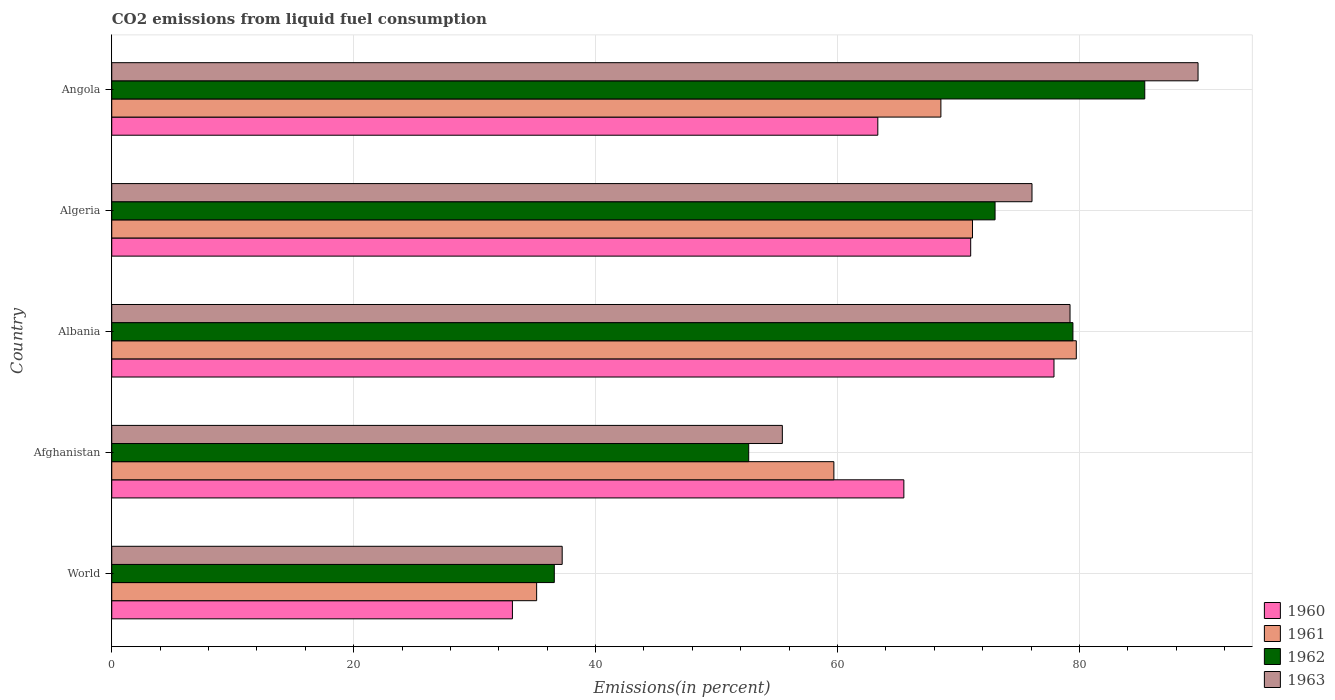How many groups of bars are there?
Provide a succinct answer. 5. Are the number of bars per tick equal to the number of legend labels?
Make the answer very short. Yes. How many bars are there on the 5th tick from the bottom?
Give a very brief answer. 4. What is the label of the 2nd group of bars from the top?
Your answer should be compact. Algeria. In how many cases, is the number of bars for a given country not equal to the number of legend labels?
Ensure brevity in your answer.  0. What is the total CO2 emitted in 1960 in World?
Provide a short and direct response. 33.13. Across all countries, what is the maximum total CO2 emitted in 1963?
Provide a succinct answer. 89.81. Across all countries, what is the minimum total CO2 emitted in 1961?
Offer a very short reply. 35.13. In which country was the total CO2 emitted in 1963 maximum?
Make the answer very short. Angola. In which country was the total CO2 emitted in 1961 minimum?
Ensure brevity in your answer.  World. What is the total total CO2 emitted in 1962 in the graph?
Provide a succinct answer. 327.14. What is the difference between the total CO2 emitted in 1961 in Afghanistan and that in World?
Your response must be concise. 24.57. What is the difference between the total CO2 emitted in 1960 in World and the total CO2 emitted in 1961 in Angola?
Offer a very short reply. -35.42. What is the average total CO2 emitted in 1962 per country?
Ensure brevity in your answer.  65.43. What is the difference between the total CO2 emitted in 1962 and total CO2 emitted in 1960 in Albania?
Your answer should be very brief. 1.57. In how many countries, is the total CO2 emitted in 1961 greater than 44 %?
Your answer should be compact. 4. What is the ratio of the total CO2 emitted in 1961 in Albania to that in World?
Offer a terse response. 2.27. What is the difference between the highest and the second highest total CO2 emitted in 1963?
Offer a terse response. 10.58. What is the difference between the highest and the lowest total CO2 emitted in 1962?
Your response must be concise. 48.82. In how many countries, is the total CO2 emitted in 1961 greater than the average total CO2 emitted in 1961 taken over all countries?
Your answer should be very brief. 3. Is the sum of the total CO2 emitted in 1961 in Albania and World greater than the maximum total CO2 emitted in 1963 across all countries?
Your response must be concise. Yes. Is it the case that in every country, the sum of the total CO2 emitted in 1961 and total CO2 emitted in 1962 is greater than the sum of total CO2 emitted in 1960 and total CO2 emitted in 1963?
Keep it short and to the point. No. What does the 2nd bar from the top in Algeria represents?
Your answer should be compact. 1962. What is the difference between two consecutive major ticks on the X-axis?
Your response must be concise. 20. Are the values on the major ticks of X-axis written in scientific E-notation?
Your response must be concise. No. Does the graph contain grids?
Provide a short and direct response. Yes. Where does the legend appear in the graph?
Your answer should be compact. Bottom right. How many legend labels are there?
Your answer should be compact. 4. What is the title of the graph?
Give a very brief answer. CO2 emissions from liquid fuel consumption. What is the label or title of the X-axis?
Provide a succinct answer. Emissions(in percent). What is the Emissions(in percent) in 1960 in World?
Keep it short and to the point. 33.13. What is the Emissions(in percent) in 1961 in World?
Your response must be concise. 35.13. What is the Emissions(in percent) of 1962 in World?
Make the answer very short. 36.59. What is the Emissions(in percent) in 1963 in World?
Give a very brief answer. 37.24. What is the Emissions(in percent) of 1960 in Afghanistan?
Your answer should be very brief. 65.49. What is the Emissions(in percent) of 1961 in Afghanistan?
Keep it short and to the point. 59.7. What is the Emissions(in percent) of 1962 in Afghanistan?
Provide a short and direct response. 52.66. What is the Emissions(in percent) of 1963 in Afghanistan?
Your answer should be very brief. 55.44. What is the Emissions(in percent) of 1960 in Albania?
Offer a terse response. 77.9. What is the Emissions(in percent) in 1961 in Albania?
Provide a short and direct response. 79.74. What is the Emissions(in percent) in 1962 in Albania?
Offer a terse response. 79.46. What is the Emissions(in percent) of 1963 in Albania?
Give a very brief answer. 79.23. What is the Emissions(in percent) in 1960 in Algeria?
Make the answer very short. 71.01. What is the Emissions(in percent) in 1961 in Algeria?
Make the answer very short. 71.16. What is the Emissions(in percent) in 1962 in Algeria?
Your response must be concise. 73.03. What is the Emissions(in percent) of 1963 in Algeria?
Your answer should be compact. 76.08. What is the Emissions(in percent) of 1960 in Angola?
Offer a very short reply. 63.33. What is the Emissions(in percent) of 1961 in Angola?
Make the answer very short. 68.55. What is the Emissions(in percent) in 1962 in Angola?
Offer a terse response. 85.4. What is the Emissions(in percent) of 1963 in Angola?
Provide a succinct answer. 89.81. Across all countries, what is the maximum Emissions(in percent) of 1960?
Your answer should be very brief. 77.9. Across all countries, what is the maximum Emissions(in percent) in 1961?
Offer a very short reply. 79.74. Across all countries, what is the maximum Emissions(in percent) in 1962?
Your answer should be very brief. 85.4. Across all countries, what is the maximum Emissions(in percent) in 1963?
Your answer should be very brief. 89.81. Across all countries, what is the minimum Emissions(in percent) in 1960?
Keep it short and to the point. 33.13. Across all countries, what is the minimum Emissions(in percent) in 1961?
Give a very brief answer. 35.13. Across all countries, what is the minimum Emissions(in percent) in 1962?
Your answer should be compact. 36.59. Across all countries, what is the minimum Emissions(in percent) of 1963?
Ensure brevity in your answer.  37.24. What is the total Emissions(in percent) of 1960 in the graph?
Your response must be concise. 310.86. What is the total Emissions(in percent) in 1961 in the graph?
Your answer should be very brief. 314.28. What is the total Emissions(in percent) in 1962 in the graph?
Offer a very short reply. 327.14. What is the total Emissions(in percent) of 1963 in the graph?
Provide a succinct answer. 337.8. What is the difference between the Emissions(in percent) in 1960 in World and that in Afghanistan?
Your answer should be very brief. -32.36. What is the difference between the Emissions(in percent) of 1961 in World and that in Afghanistan?
Ensure brevity in your answer.  -24.57. What is the difference between the Emissions(in percent) of 1962 in World and that in Afghanistan?
Give a very brief answer. -16.07. What is the difference between the Emissions(in percent) of 1963 in World and that in Afghanistan?
Provide a short and direct response. -18.2. What is the difference between the Emissions(in percent) in 1960 in World and that in Albania?
Provide a short and direct response. -44.77. What is the difference between the Emissions(in percent) in 1961 in World and that in Albania?
Your response must be concise. -44.61. What is the difference between the Emissions(in percent) of 1962 in World and that in Albania?
Provide a short and direct response. -42.88. What is the difference between the Emissions(in percent) of 1963 in World and that in Albania?
Provide a succinct answer. -41.99. What is the difference between the Emissions(in percent) in 1960 in World and that in Algeria?
Offer a terse response. -37.89. What is the difference between the Emissions(in percent) of 1961 in World and that in Algeria?
Keep it short and to the point. -36.03. What is the difference between the Emissions(in percent) of 1962 in World and that in Algeria?
Give a very brief answer. -36.44. What is the difference between the Emissions(in percent) of 1963 in World and that in Algeria?
Ensure brevity in your answer.  -38.84. What is the difference between the Emissions(in percent) in 1960 in World and that in Angola?
Ensure brevity in your answer.  -30.21. What is the difference between the Emissions(in percent) of 1961 in World and that in Angola?
Make the answer very short. -33.42. What is the difference between the Emissions(in percent) in 1962 in World and that in Angola?
Offer a very short reply. -48.82. What is the difference between the Emissions(in percent) of 1963 in World and that in Angola?
Your response must be concise. -52.57. What is the difference between the Emissions(in percent) of 1960 in Afghanistan and that in Albania?
Your answer should be compact. -12.41. What is the difference between the Emissions(in percent) of 1961 in Afghanistan and that in Albania?
Provide a succinct answer. -20.04. What is the difference between the Emissions(in percent) of 1962 in Afghanistan and that in Albania?
Keep it short and to the point. -26.8. What is the difference between the Emissions(in percent) of 1963 in Afghanistan and that in Albania?
Provide a short and direct response. -23.78. What is the difference between the Emissions(in percent) in 1960 in Afghanistan and that in Algeria?
Your answer should be very brief. -5.53. What is the difference between the Emissions(in percent) of 1961 in Afghanistan and that in Algeria?
Provide a succinct answer. -11.46. What is the difference between the Emissions(in percent) in 1962 in Afghanistan and that in Algeria?
Your response must be concise. -20.37. What is the difference between the Emissions(in percent) in 1963 in Afghanistan and that in Algeria?
Give a very brief answer. -20.64. What is the difference between the Emissions(in percent) in 1960 in Afghanistan and that in Angola?
Offer a terse response. 2.15. What is the difference between the Emissions(in percent) of 1961 in Afghanistan and that in Angola?
Your answer should be very brief. -8.85. What is the difference between the Emissions(in percent) in 1962 in Afghanistan and that in Angola?
Provide a succinct answer. -32.74. What is the difference between the Emissions(in percent) in 1963 in Afghanistan and that in Angola?
Keep it short and to the point. -34.37. What is the difference between the Emissions(in percent) in 1960 in Albania and that in Algeria?
Give a very brief answer. 6.89. What is the difference between the Emissions(in percent) of 1961 in Albania and that in Algeria?
Make the answer very short. 8.58. What is the difference between the Emissions(in percent) in 1962 in Albania and that in Algeria?
Offer a terse response. 6.44. What is the difference between the Emissions(in percent) in 1963 in Albania and that in Algeria?
Keep it short and to the point. 3.14. What is the difference between the Emissions(in percent) in 1960 in Albania and that in Angola?
Make the answer very short. 14.57. What is the difference between the Emissions(in percent) of 1961 in Albania and that in Angola?
Make the answer very short. 11.19. What is the difference between the Emissions(in percent) of 1962 in Albania and that in Angola?
Offer a terse response. -5.94. What is the difference between the Emissions(in percent) of 1963 in Albania and that in Angola?
Offer a terse response. -10.58. What is the difference between the Emissions(in percent) in 1960 in Algeria and that in Angola?
Keep it short and to the point. 7.68. What is the difference between the Emissions(in percent) of 1961 in Algeria and that in Angola?
Your answer should be very brief. 2.61. What is the difference between the Emissions(in percent) in 1962 in Algeria and that in Angola?
Keep it short and to the point. -12.38. What is the difference between the Emissions(in percent) in 1963 in Algeria and that in Angola?
Provide a short and direct response. -13.73. What is the difference between the Emissions(in percent) in 1960 in World and the Emissions(in percent) in 1961 in Afghanistan?
Your answer should be very brief. -26.58. What is the difference between the Emissions(in percent) in 1960 in World and the Emissions(in percent) in 1962 in Afghanistan?
Keep it short and to the point. -19.53. What is the difference between the Emissions(in percent) in 1960 in World and the Emissions(in percent) in 1963 in Afghanistan?
Offer a very short reply. -22.32. What is the difference between the Emissions(in percent) of 1961 in World and the Emissions(in percent) of 1962 in Afghanistan?
Offer a terse response. -17.53. What is the difference between the Emissions(in percent) of 1961 in World and the Emissions(in percent) of 1963 in Afghanistan?
Your answer should be compact. -20.31. What is the difference between the Emissions(in percent) of 1962 in World and the Emissions(in percent) of 1963 in Afghanistan?
Your answer should be compact. -18.85. What is the difference between the Emissions(in percent) of 1960 in World and the Emissions(in percent) of 1961 in Albania?
Offer a terse response. -46.62. What is the difference between the Emissions(in percent) in 1960 in World and the Emissions(in percent) in 1962 in Albania?
Your answer should be very brief. -46.34. What is the difference between the Emissions(in percent) in 1960 in World and the Emissions(in percent) in 1963 in Albania?
Offer a terse response. -46.1. What is the difference between the Emissions(in percent) in 1961 in World and the Emissions(in percent) in 1962 in Albania?
Your answer should be very brief. -44.34. What is the difference between the Emissions(in percent) of 1961 in World and the Emissions(in percent) of 1963 in Albania?
Offer a very short reply. -44.1. What is the difference between the Emissions(in percent) in 1962 in World and the Emissions(in percent) in 1963 in Albania?
Offer a very short reply. -42.64. What is the difference between the Emissions(in percent) of 1960 in World and the Emissions(in percent) of 1961 in Algeria?
Offer a very short reply. -38.04. What is the difference between the Emissions(in percent) of 1960 in World and the Emissions(in percent) of 1962 in Algeria?
Ensure brevity in your answer.  -39.9. What is the difference between the Emissions(in percent) of 1960 in World and the Emissions(in percent) of 1963 in Algeria?
Ensure brevity in your answer.  -42.96. What is the difference between the Emissions(in percent) in 1961 in World and the Emissions(in percent) in 1962 in Algeria?
Your answer should be very brief. -37.9. What is the difference between the Emissions(in percent) of 1961 in World and the Emissions(in percent) of 1963 in Algeria?
Provide a succinct answer. -40.95. What is the difference between the Emissions(in percent) of 1962 in World and the Emissions(in percent) of 1963 in Algeria?
Offer a terse response. -39.49. What is the difference between the Emissions(in percent) of 1960 in World and the Emissions(in percent) of 1961 in Angola?
Ensure brevity in your answer.  -35.42. What is the difference between the Emissions(in percent) in 1960 in World and the Emissions(in percent) in 1962 in Angola?
Keep it short and to the point. -52.28. What is the difference between the Emissions(in percent) in 1960 in World and the Emissions(in percent) in 1963 in Angola?
Provide a succinct answer. -56.68. What is the difference between the Emissions(in percent) in 1961 in World and the Emissions(in percent) in 1962 in Angola?
Your answer should be compact. -50.28. What is the difference between the Emissions(in percent) of 1961 in World and the Emissions(in percent) of 1963 in Angola?
Give a very brief answer. -54.68. What is the difference between the Emissions(in percent) of 1962 in World and the Emissions(in percent) of 1963 in Angola?
Provide a short and direct response. -53.22. What is the difference between the Emissions(in percent) of 1960 in Afghanistan and the Emissions(in percent) of 1961 in Albania?
Make the answer very short. -14.26. What is the difference between the Emissions(in percent) in 1960 in Afghanistan and the Emissions(in percent) in 1962 in Albania?
Ensure brevity in your answer.  -13.98. What is the difference between the Emissions(in percent) of 1960 in Afghanistan and the Emissions(in percent) of 1963 in Albania?
Offer a very short reply. -13.74. What is the difference between the Emissions(in percent) in 1961 in Afghanistan and the Emissions(in percent) in 1962 in Albania?
Your response must be concise. -19.76. What is the difference between the Emissions(in percent) of 1961 in Afghanistan and the Emissions(in percent) of 1963 in Albania?
Keep it short and to the point. -19.52. What is the difference between the Emissions(in percent) in 1962 in Afghanistan and the Emissions(in percent) in 1963 in Albania?
Provide a succinct answer. -26.57. What is the difference between the Emissions(in percent) of 1960 in Afghanistan and the Emissions(in percent) of 1961 in Algeria?
Give a very brief answer. -5.67. What is the difference between the Emissions(in percent) of 1960 in Afghanistan and the Emissions(in percent) of 1962 in Algeria?
Ensure brevity in your answer.  -7.54. What is the difference between the Emissions(in percent) in 1960 in Afghanistan and the Emissions(in percent) in 1963 in Algeria?
Give a very brief answer. -10.59. What is the difference between the Emissions(in percent) of 1961 in Afghanistan and the Emissions(in percent) of 1962 in Algeria?
Your answer should be compact. -13.33. What is the difference between the Emissions(in percent) of 1961 in Afghanistan and the Emissions(in percent) of 1963 in Algeria?
Give a very brief answer. -16.38. What is the difference between the Emissions(in percent) of 1962 in Afghanistan and the Emissions(in percent) of 1963 in Algeria?
Provide a succinct answer. -23.42. What is the difference between the Emissions(in percent) of 1960 in Afghanistan and the Emissions(in percent) of 1961 in Angola?
Give a very brief answer. -3.06. What is the difference between the Emissions(in percent) of 1960 in Afghanistan and the Emissions(in percent) of 1962 in Angola?
Ensure brevity in your answer.  -19.92. What is the difference between the Emissions(in percent) of 1960 in Afghanistan and the Emissions(in percent) of 1963 in Angola?
Ensure brevity in your answer.  -24.32. What is the difference between the Emissions(in percent) in 1961 in Afghanistan and the Emissions(in percent) in 1962 in Angola?
Offer a very short reply. -25.7. What is the difference between the Emissions(in percent) in 1961 in Afghanistan and the Emissions(in percent) in 1963 in Angola?
Keep it short and to the point. -30.11. What is the difference between the Emissions(in percent) of 1962 in Afghanistan and the Emissions(in percent) of 1963 in Angola?
Your answer should be compact. -37.15. What is the difference between the Emissions(in percent) in 1960 in Albania and the Emissions(in percent) in 1961 in Algeria?
Ensure brevity in your answer.  6.74. What is the difference between the Emissions(in percent) of 1960 in Albania and the Emissions(in percent) of 1962 in Algeria?
Your answer should be very brief. 4.87. What is the difference between the Emissions(in percent) in 1960 in Albania and the Emissions(in percent) in 1963 in Algeria?
Your answer should be very brief. 1.82. What is the difference between the Emissions(in percent) of 1961 in Albania and the Emissions(in percent) of 1962 in Algeria?
Provide a short and direct response. 6.72. What is the difference between the Emissions(in percent) of 1961 in Albania and the Emissions(in percent) of 1963 in Algeria?
Keep it short and to the point. 3.66. What is the difference between the Emissions(in percent) of 1962 in Albania and the Emissions(in percent) of 1963 in Algeria?
Provide a short and direct response. 3.38. What is the difference between the Emissions(in percent) of 1960 in Albania and the Emissions(in percent) of 1961 in Angola?
Ensure brevity in your answer.  9.35. What is the difference between the Emissions(in percent) in 1960 in Albania and the Emissions(in percent) in 1962 in Angola?
Ensure brevity in your answer.  -7.51. What is the difference between the Emissions(in percent) in 1960 in Albania and the Emissions(in percent) in 1963 in Angola?
Provide a succinct answer. -11.91. What is the difference between the Emissions(in percent) of 1961 in Albania and the Emissions(in percent) of 1962 in Angola?
Give a very brief answer. -5.66. What is the difference between the Emissions(in percent) of 1961 in Albania and the Emissions(in percent) of 1963 in Angola?
Offer a very short reply. -10.07. What is the difference between the Emissions(in percent) in 1962 in Albania and the Emissions(in percent) in 1963 in Angola?
Give a very brief answer. -10.34. What is the difference between the Emissions(in percent) in 1960 in Algeria and the Emissions(in percent) in 1961 in Angola?
Offer a very short reply. 2.46. What is the difference between the Emissions(in percent) in 1960 in Algeria and the Emissions(in percent) in 1962 in Angola?
Offer a terse response. -14.39. What is the difference between the Emissions(in percent) of 1960 in Algeria and the Emissions(in percent) of 1963 in Angola?
Offer a very short reply. -18.8. What is the difference between the Emissions(in percent) of 1961 in Algeria and the Emissions(in percent) of 1962 in Angola?
Offer a terse response. -14.24. What is the difference between the Emissions(in percent) of 1961 in Algeria and the Emissions(in percent) of 1963 in Angola?
Keep it short and to the point. -18.65. What is the difference between the Emissions(in percent) in 1962 in Algeria and the Emissions(in percent) in 1963 in Angola?
Your response must be concise. -16.78. What is the average Emissions(in percent) of 1960 per country?
Provide a succinct answer. 62.17. What is the average Emissions(in percent) of 1961 per country?
Provide a succinct answer. 62.86. What is the average Emissions(in percent) in 1962 per country?
Keep it short and to the point. 65.43. What is the average Emissions(in percent) in 1963 per country?
Ensure brevity in your answer.  67.56. What is the difference between the Emissions(in percent) in 1960 and Emissions(in percent) in 1961 in World?
Your answer should be compact. -2. What is the difference between the Emissions(in percent) in 1960 and Emissions(in percent) in 1962 in World?
Offer a very short reply. -3.46. What is the difference between the Emissions(in percent) in 1960 and Emissions(in percent) in 1963 in World?
Make the answer very short. -4.11. What is the difference between the Emissions(in percent) in 1961 and Emissions(in percent) in 1962 in World?
Provide a succinct answer. -1.46. What is the difference between the Emissions(in percent) of 1961 and Emissions(in percent) of 1963 in World?
Provide a succinct answer. -2.11. What is the difference between the Emissions(in percent) in 1962 and Emissions(in percent) in 1963 in World?
Your response must be concise. -0.65. What is the difference between the Emissions(in percent) of 1960 and Emissions(in percent) of 1961 in Afghanistan?
Provide a succinct answer. 5.79. What is the difference between the Emissions(in percent) in 1960 and Emissions(in percent) in 1962 in Afghanistan?
Your response must be concise. 12.83. What is the difference between the Emissions(in percent) in 1960 and Emissions(in percent) in 1963 in Afghanistan?
Provide a succinct answer. 10.05. What is the difference between the Emissions(in percent) in 1961 and Emissions(in percent) in 1962 in Afghanistan?
Keep it short and to the point. 7.04. What is the difference between the Emissions(in percent) of 1961 and Emissions(in percent) of 1963 in Afghanistan?
Your response must be concise. 4.26. What is the difference between the Emissions(in percent) of 1962 and Emissions(in percent) of 1963 in Afghanistan?
Ensure brevity in your answer.  -2.78. What is the difference between the Emissions(in percent) of 1960 and Emissions(in percent) of 1961 in Albania?
Provide a short and direct response. -1.84. What is the difference between the Emissions(in percent) of 1960 and Emissions(in percent) of 1962 in Albania?
Your answer should be very brief. -1.57. What is the difference between the Emissions(in percent) of 1960 and Emissions(in percent) of 1963 in Albania?
Provide a succinct answer. -1.33. What is the difference between the Emissions(in percent) in 1961 and Emissions(in percent) in 1962 in Albania?
Ensure brevity in your answer.  0.28. What is the difference between the Emissions(in percent) in 1961 and Emissions(in percent) in 1963 in Albania?
Keep it short and to the point. 0.52. What is the difference between the Emissions(in percent) of 1962 and Emissions(in percent) of 1963 in Albania?
Offer a very short reply. 0.24. What is the difference between the Emissions(in percent) of 1960 and Emissions(in percent) of 1961 in Algeria?
Your response must be concise. -0.15. What is the difference between the Emissions(in percent) of 1960 and Emissions(in percent) of 1962 in Algeria?
Give a very brief answer. -2.02. What is the difference between the Emissions(in percent) in 1960 and Emissions(in percent) in 1963 in Algeria?
Offer a very short reply. -5.07. What is the difference between the Emissions(in percent) in 1961 and Emissions(in percent) in 1962 in Algeria?
Your answer should be compact. -1.87. What is the difference between the Emissions(in percent) in 1961 and Emissions(in percent) in 1963 in Algeria?
Provide a short and direct response. -4.92. What is the difference between the Emissions(in percent) in 1962 and Emissions(in percent) in 1963 in Algeria?
Ensure brevity in your answer.  -3.05. What is the difference between the Emissions(in percent) in 1960 and Emissions(in percent) in 1961 in Angola?
Give a very brief answer. -5.22. What is the difference between the Emissions(in percent) of 1960 and Emissions(in percent) of 1962 in Angola?
Your answer should be compact. -22.07. What is the difference between the Emissions(in percent) of 1960 and Emissions(in percent) of 1963 in Angola?
Offer a terse response. -26.48. What is the difference between the Emissions(in percent) of 1961 and Emissions(in percent) of 1962 in Angola?
Keep it short and to the point. -16.86. What is the difference between the Emissions(in percent) in 1961 and Emissions(in percent) in 1963 in Angola?
Offer a very short reply. -21.26. What is the difference between the Emissions(in percent) of 1962 and Emissions(in percent) of 1963 in Angola?
Your response must be concise. -4.41. What is the ratio of the Emissions(in percent) of 1960 in World to that in Afghanistan?
Give a very brief answer. 0.51. What is the ratio of the Emissions(in percent) in 1961 in World to that in Afghanistan?
Offer a terse response. 0.59. What is the ratio of the Emissions(in percent) of 1962 in World to that in Afghanistan?
Ensure brevity in your answer.  0.69. What is the ratio of the Emissions(in percent) of 1963 in World to that in Afghanistan?
Provide a short and direct response. 0.67. What is the ratio of the Emissions(in percent) in 1960 in World to that in Albania?
Your answer should be very brief. 0.43. What is the ratio of the Emissions(in percent) of 1961 in World to that in Albania?
Your answer should be very brief. 0.44. What is the ratio of the Emissions(in percent) of 1962 in World to that in Albania?
Provide a succinct answer. 0.46. What is the ratio of the Emissions(in percent) of 1963 in World to that in Albania?
Offer a terse response. 0.47. What is the ratio of the Emissions(in percent) in 1960 in World to that in Algeria?
Offer a terse response. 0.47. What is the ratio of the Emissions(in percent) in 1961 in World to that in Algeria?
Provide a short and direct response. 0.49. What is the ratio of the Emissions(in percent) of 1962 in World to that in Algeria?
Your answer should be very brief. 0.5. What is the ratio of the Emissions(in percent) in 1963 in World to that in Algeria?
Give a very brief answer. 0.49. What is the ratio of the Emissions(in percent) in 1960 in World to that in Angola?
Keep it short and to the point. 0.52. What is the ratio of the Emissions(in percent) in 1961 in World to that in Angola?
Your response must be concise. 0.51. What is the ratio of the Emissions(in percent) in 1962 in World to that in Angola?
Ensure brevity in your answer.  0.43. What is the ratio of the Emissions(in percent) in 1963 in World to that in Angola?
Your answer should be compact. 0.41. What is the ratio of the Emissions(in percent) in 1960 in Afghanistan to that in Albania?
Provide a succinct answer. 0.84. What is the ratio of the Emissions(in percent) in 1961 in Afghanistan to that in Albania?
Your answer should be compact. 0.75. What is the ratio of the Emissions(in percent) in 1962 in Afghanistan to that in Albania?
Provide a succinct answer. 0.66. What is the ratio of the Emissions(in percent) of 1963 in Afghanistan to that in Albania?
Offer a terse response. 0.7. What is the ratio of the Emissions(in percent) in 1960 in Afghanistan to that in Algeria?
Your answer should be compact. 0.92. What is the ratio of the Emissions(in percent) of 1961 in Afghanistan to that in Algeria?
Give a very brief answer. 0.84. What is the ratio of the Emissions(in percent) in 1962 in Afghanistan to that in Algeria?
Provide a succinct answer. 0.72. What is the ratio of the Emissions(in percent) in 1963 in Afghanistan to that in Algeria?
Provide a short and direct response. 0.73. What is the ratio of the Emissions(in percent) in 1960 in Afghanistan to that in Angola?
Ensure brevity in your answer.  1.03. What is the ratio of the Emissions(in percent) in 1961 in Afghanistan to that in Angola?
Ensure brevity in your answer.  0.87. What is the ratio of the Emissions(in percent) in 1962 in Afghanistan to that in Angola?
Give a very brief answer. 0.62. What is the ratio of the Emissions(in percent) of 1963 in Afghanistan to that in Angola?
Ensure brevity in your answer.  0.62. What is the ratio of the Emissions(in percent) in 1960 in Albania to that in Algeria?
Keep it short and to the point. 1.1. What is the ratio of the Emissions(in percent) of 1961 in Albania to that in Algeria?
Offer a terse response. 1.12. What is the ratio of the Emissions(in percent) in 1962 in Albania to that in Algeria?
Keep it short and to the point. 1.09. What is the ratio of the Emissions(in percent) in 1963 in Albania to that in Algeria?
Ensure brevity in your answer.  1.04. What is the ratio of the Emissions(in percent) in 1960 in Albania to that in Angola?
Give a very brief answer. 1.23. What is the ratio of the Emissions(in percent) of 1961 in Albania to that in Angola?
Make the answer very short. 1.16. What is the ratio of the Emissions(in percent) of 1962 in Albania to that in Angola?
Your answer should be compact. 0.93. What is the ratio of the Emissions(in percent) of 1963 in Albania to that in Angola?
Offer a very short reply. 0.88. What is the ratio of the Emissions(in percent) of 1960 in Algeria to that in Angola?
Make the answer very short. 1.12. What is the ratio of the Emissions(in percent) of 1961 in Algeria to that in Angola?
Make the answer very short. 1.04. What is the ratio of the Emissions(in percent) in 1962 in Algeria to that in Angola?
Your answer should be very brief. 0.86. What is the ratio of the Emissions(in percent) in 1963 in Algeria to that in Angola?
Your answer should be very brief. 0.85. What is the difference between the highest and the second highest Emissions(in percent) in 1960?
Offer a terse response. 6.89. What is the difference between the highest and the second highest Emissions(in percent) in 1961?
Your answer should be very brief. 8.58. What is the difference between the highest and the second highest Emissions(in percent) of 1962?
Offer a terse response. 5.94. What is the difference between the highest and the second highest Emissions(in percent) of 1963?
Give a very brief answer. 10.58. What is the difference between the highest and the lowest Emissions(in percent) in 1960?
Give a very brief answer. 44.77. What is the difference between the highest and the lowest Emissions(in percent) in 1961?
Provide a short and direct response. 44.61. What is the difference between the highest and the lowest Emissions(in percent) of 1962?
Your response must be concise. 48.82. What is the difference between the highest and the lowest Emissions(in percent) of 1963?
Keep it short and to the point. 52.57. 